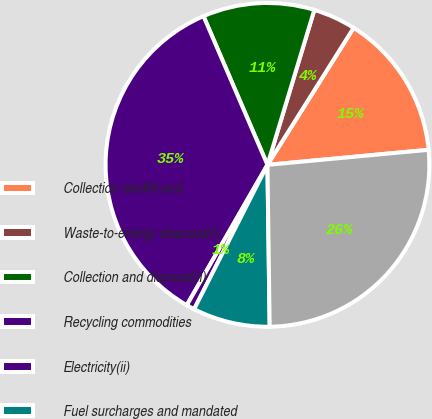<chart> <loc_0><loc_0><loc_500><loc_500><pie_chart><fcel>Collection landfill and<fcel>Waste-to-energy disposal(ii)<fcel>Collection and disposal(ii)<fcel>Recycling commodities<fcel>Electricity(ii)<fcel>Fuel surcharges and mandated<fcel>Total<nl><fcel>14.58%<fcel>4.26%<fcel>11.14%<fcel>35.23%<fcel>0.82%<fcel>7.7%<fcel>26.26%<nl></chart> 